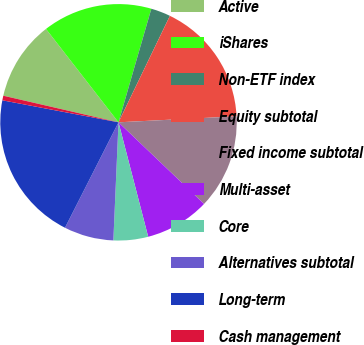<chart> <loc_0><loc_0><loc_500><loc_500><pie_chart><fcel>Active<fcel>iShares<fcel>Non-ETF index<fcel>Equity subtotal<fcel>Fixed income subtotal<fcel>Multi-asset<fcel>Core<fcel>Alternatives subtotal<fcel>Long-term<fcel>Cash management<nl><fcel>10.88%<fcel>14.98%<fcel>2.68%<fcel>17.03%<fcel>12.93%<fcel>8.83%<fcel>4.73%<fcel>6.78%<fcel>20.5%<fcel>0.63%<nl></chart> 